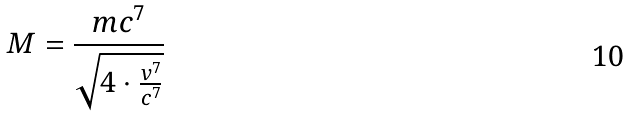Convert formula to latex. <formula><loc_0><loc_0><loc_500><loc_500>M = \frac { m c ^ { 7 } } { \sqrt { 4 \cdot \frac { v ^ { 7 } } { c ^ { 7 } } } }</formula> 